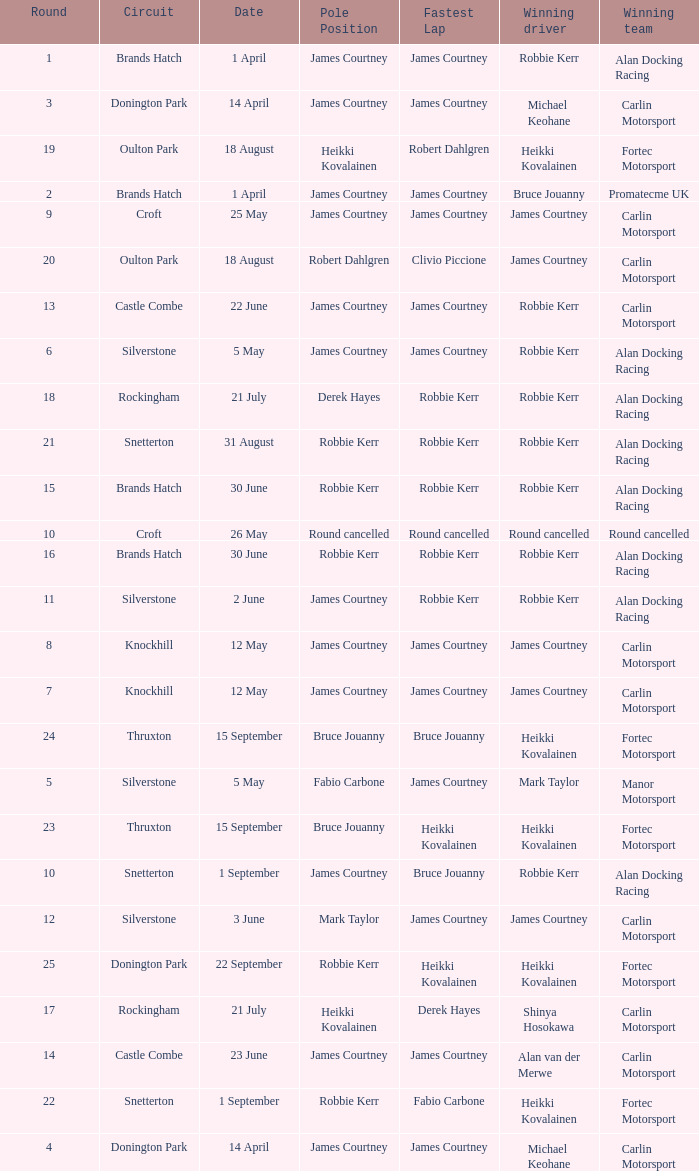What is every date of Mark Taylor as winning driver? 5 May. 